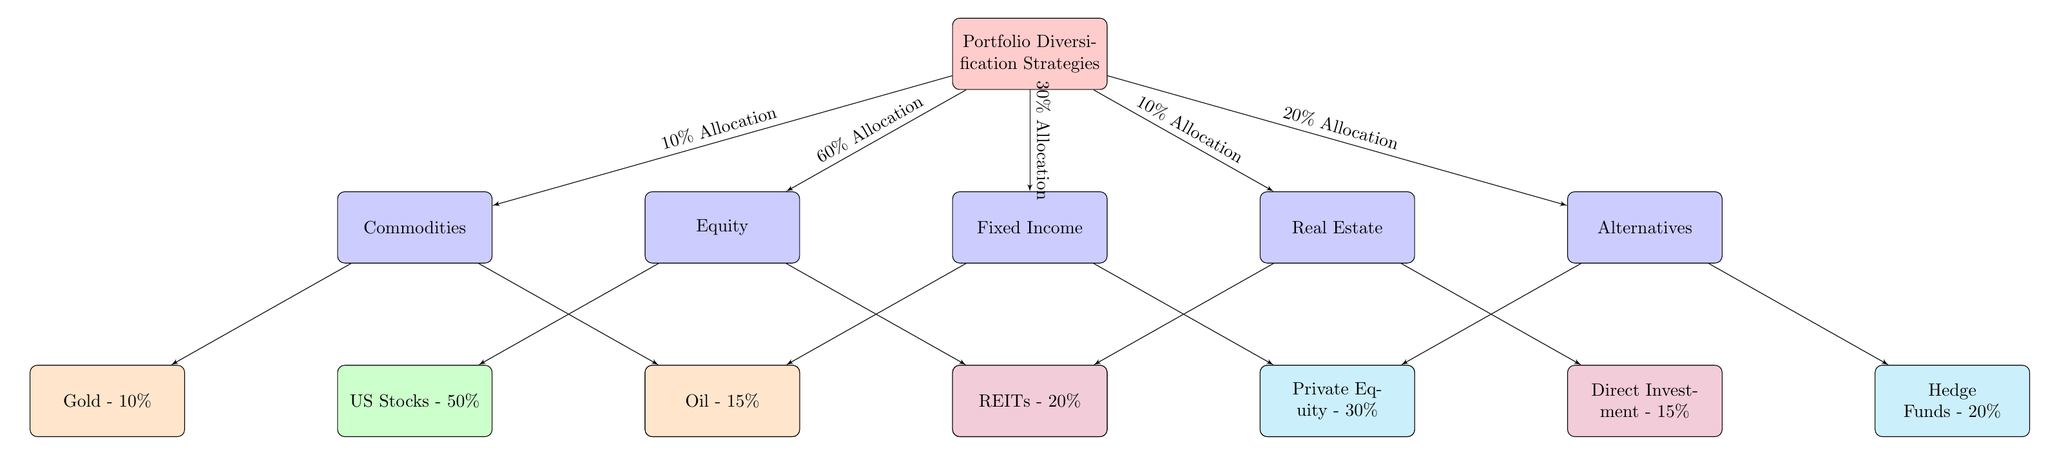What is the percentage allocation for Equity? The diagram specifies that Equity has a total allocation percentage of 60%. This is indicated at the connecting line between the main node "Portfolio Diversification Strategies" and the "Equity" node.
Answer: 60% How many subclasses does Fixed Income have? By examining the Fixed Income node, we see two direct subclasses listed: Bonds and Municipal Bonds. This is determined by the two arrows leading from the Fixed Income node to its subclasses.
Answer: 2 What are the two types of stocks listed under Equity? The subclasses of stocks identified under the Equity category are US Stocks and International Stocks. This is visible as the two nodes directly connected to Equity.
Answer: US Stocks, International Stocks What is the percentage allocation of Direct Investment? Looking at the Real Estate node in the diagram, Direct Investment is indicated to have an allocation percentage of 15%. This detail is provided within the node connected to Real Estate.
Answer: 15% What is the total allocation percentage for Alternatives? Referring to the Alternatives node, we note that the allocation percentage is equal to 20%, which is specified along the connecting line from the main portfolio strategies.
Answer: 20% What percentage of the portfolio is allocated to Bonds and Municipal Bonds combined? To find the combined allocation, we add the percentages listed for Bonds (60%) and Municipal Bonds (25%), resulting in a total of 85%. This involves summing the values of the two subclasses directly underneath the Fixed Income node.
Answer: 85% What does the Gold node represent in terms of asset allocation? The Gold node is specified within the Commodities section and indicates a 10% allocation. This value is visible in the node directly connected to Commodities.
Answer: 10% Which asset class has the highest percentage allocation in the portfolio? Upon reviewing the allocation percentages for each main asset class, Fixed Income with 30% is the largest allocation, as indicated on the connecting line to the main node.
Answer: Fixed Income What is the total percentage allocation for the Real Estate subclasses? By adding together the percentage allocations from the Real Estate subclasses, REITs (20%) and Direct Investment (15%), we find a total of 35%. This is computed by summing the values of the two nodes under Real Estate.
Answer: 35% 